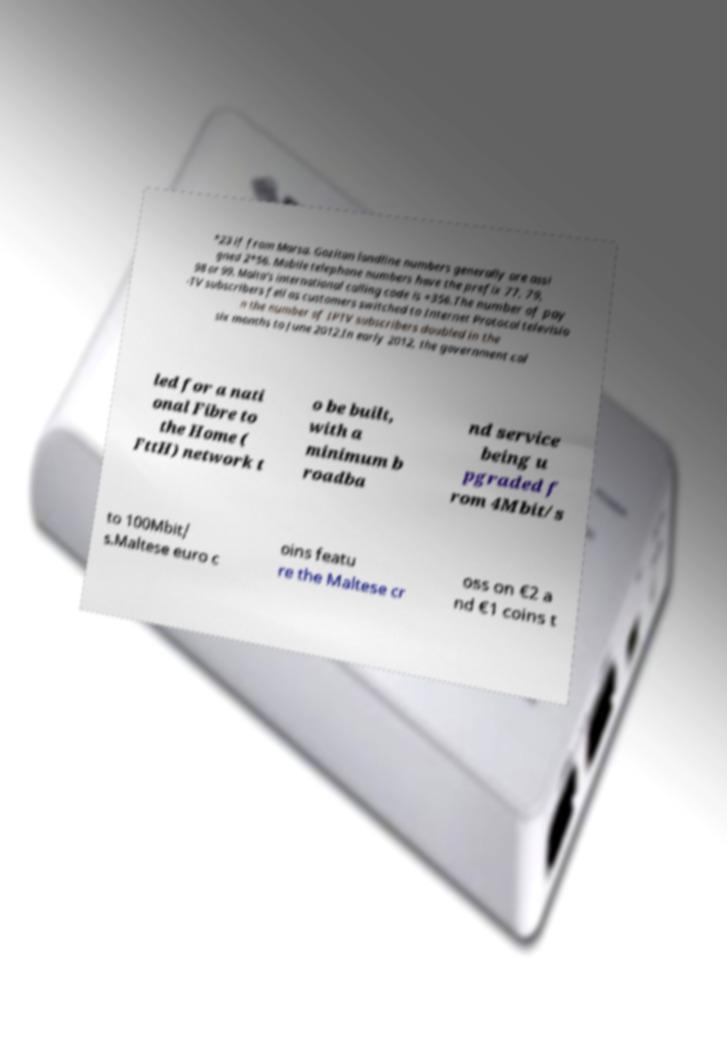There's text embedded in this image that I need extracted. Can you transcribe it verbatim? *23 if from Marsa. Gozitan landline numbers generally are assi gned 2*56. Mobile telephone numbers have the prefix 77, 79, 98 or 99. Malta's international calling code is +356.The number of pay -TV subscribers fell as customers switched to Internet Protocol televisio n the number of IPTV subscribers doubled in the six months to June 2012.In early 2012, the government cal led for a nati onal Fibre to the Home ( FttH) network t o be built, with a minimum b roadba nd service being u pgraded f rom 4Mbit/s to 100Mbit/ s.Maltese euro c oins featu re the Maltese cr oss on €2 a nd €1 coins t 